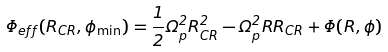Convert formula to latex. <formula><loc_0><loc_0><loc_500><loc_500>\Phi _ { e f f } ( R _ { C R } , \phi _ { \min } ) = \frac { 1 } { 2 } \Omega _ { p } ^ { 2 } R _ { C R } ^ { 2 } - \Omega _ { p } ^ { 2 } R R _ { C R } + \Phi ( R , \phi )</formula> 